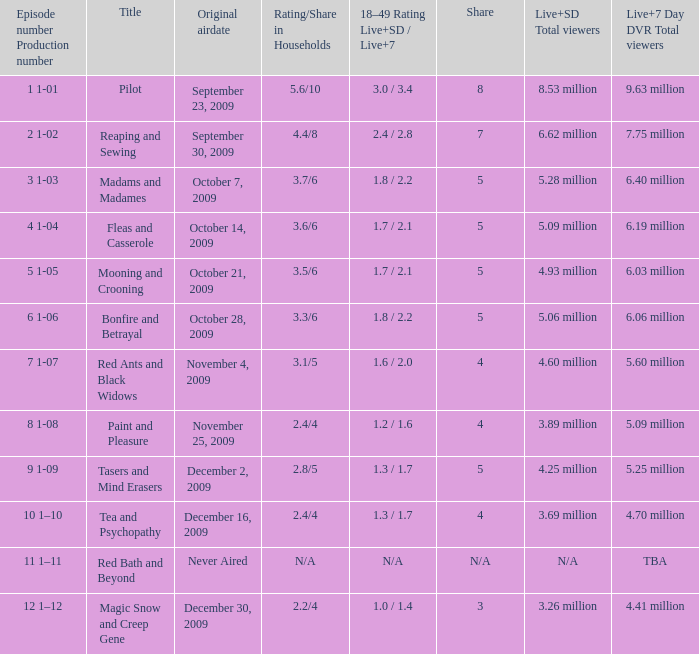When did the fourth episode of the season (4 1-04) first air? October 14, 2009. 